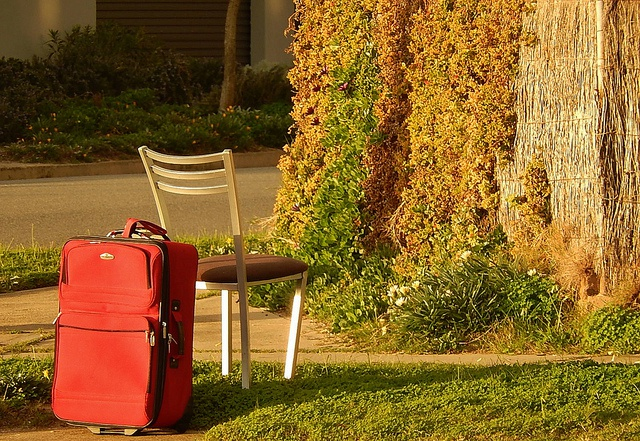Describe the objects in this image and their specific colors. I can see suitcase in olive, red, maroon, black, and salmon tones and chair in olive, maroon, and tan tones in this image. 